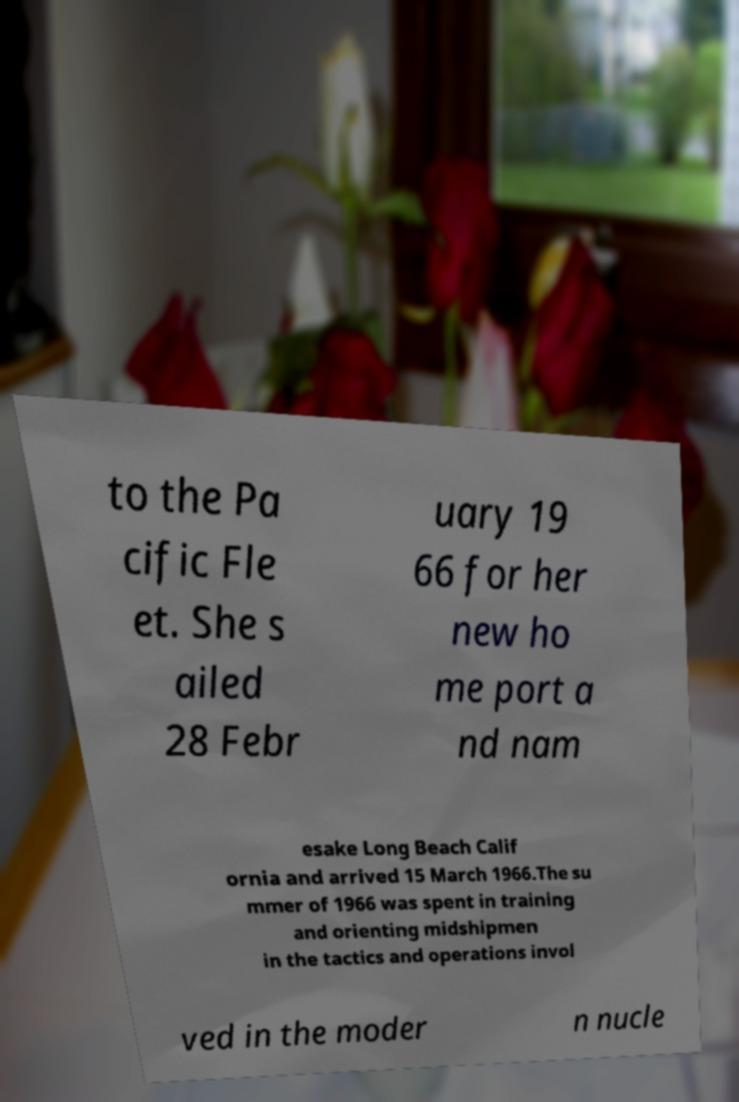Please read and relay the text visible in this image. What does it say? to the Pa cific Fle et. She s ailed 28 Febr uary 19 66 for her new ho me port a nd nam esake Long Beach Calif ornia and arrived 15 March 1966.The su mmer of 1966 was spent in training and orienting midshipmen in the tactics and operations invol ved in the moder n nucle 